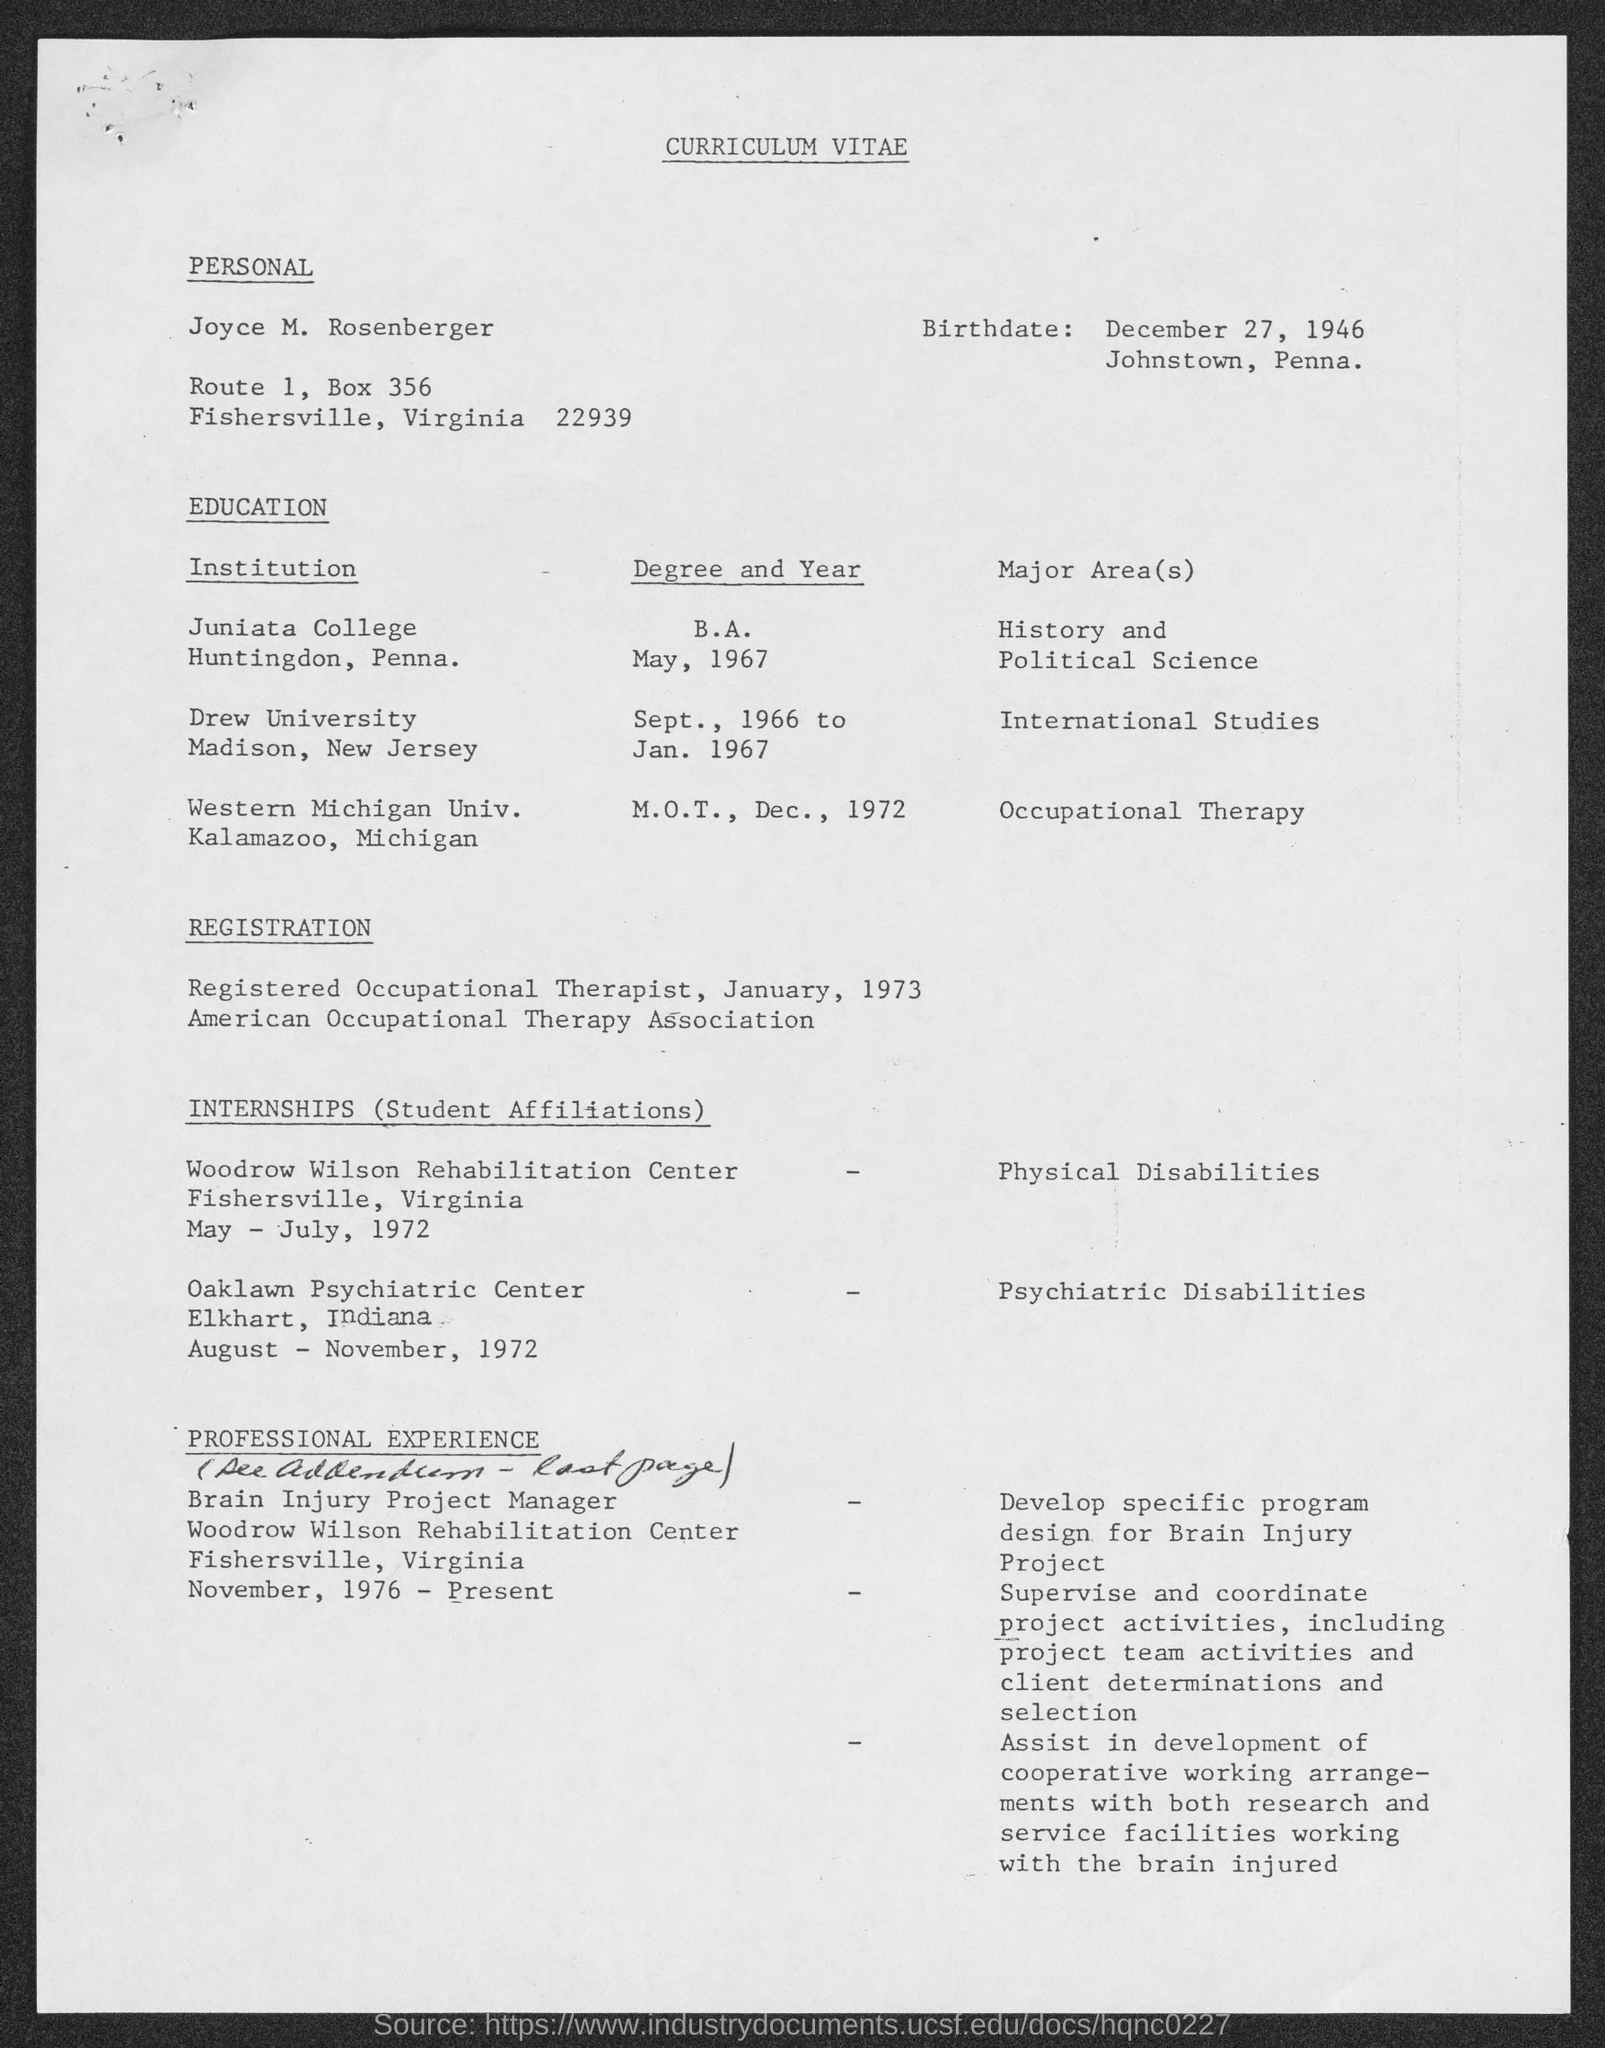What is the birthdate?
Ensure brevity in your answer.  December 27, 1946. 